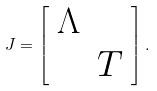<formula> <loc_0><loc_0><loc_500><loc_500>J = \left [ \begin{array} { c c } \Lambda & \\ & T \end{array} \right ] .</formula> 